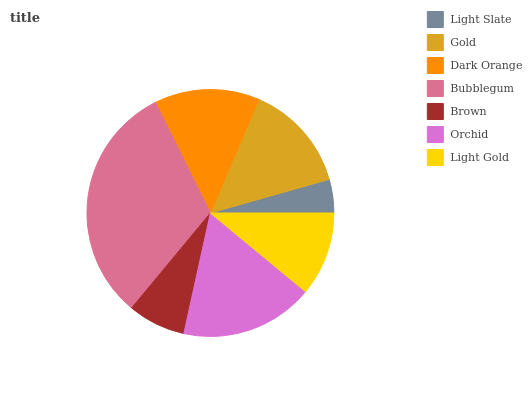Is Light Slate the minimum?
Answer yes or no. Yes. Is Bubblegum the maximum?
Answer yes or no. Yes. Is Gold the minimum?
Answer yes or no. No. Is Gold the maximum?
Answer yes or no. No. Is Gold greater than Light Slate?
Answer yes or no. Yes. Is Light Slate less than Gold?
Answer yes or no. Yes. Is Light Slate greater than Gold?
Answer yes or no. No. Is Gold less than Light Slate?
Answer yes or no. No. Is Dark Orange the high median?
Answer yes or no. Yes. Is Dark Orange the low median?
Answer yes or no. Yes. Is Light Slate the high median?
Answer yes or no. No. Is Gold the low median?
Answer yes or no. No. 